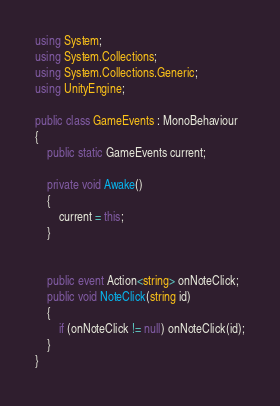<code> <loc_0><loc_0><loc_500><loc_500><_C#_>using System;
using System.Collections;
using System.Collections.Generic;
using UnityEngine;

public class GameEvents : MonoBehaviour
{
    public static GameEvents current;

    private void Awake()
    {
        current = this;
    }


    public event Action<string> onNoteClick;
    public void NoteClick(string id)
    {
        if (onNoteClick != null) onNoteClick(id);
    }
}
</code> 